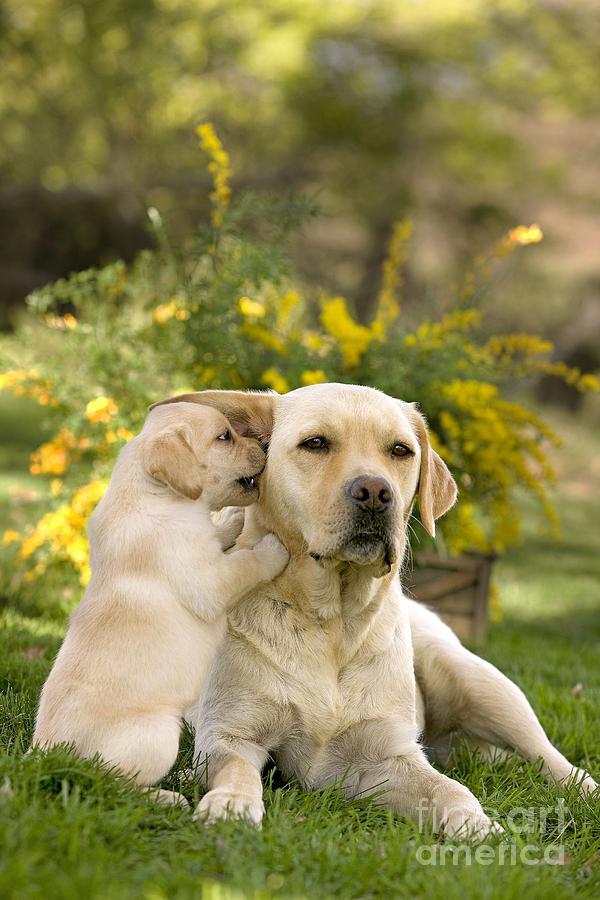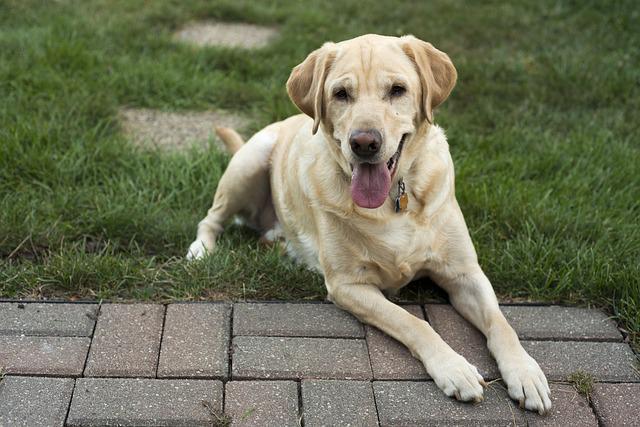The first image is the image on the left, the second image is the image on the right. Considering the images on both sides, is "There are two dogs in the left picture." valid? Answer yes or no. Yes. The first image is the image on the left, the second image is the image on the right. Considering the images on both sides, is "In at least one image there are exactly two dogs outside together." valid? Answer yes or no. Yes. 